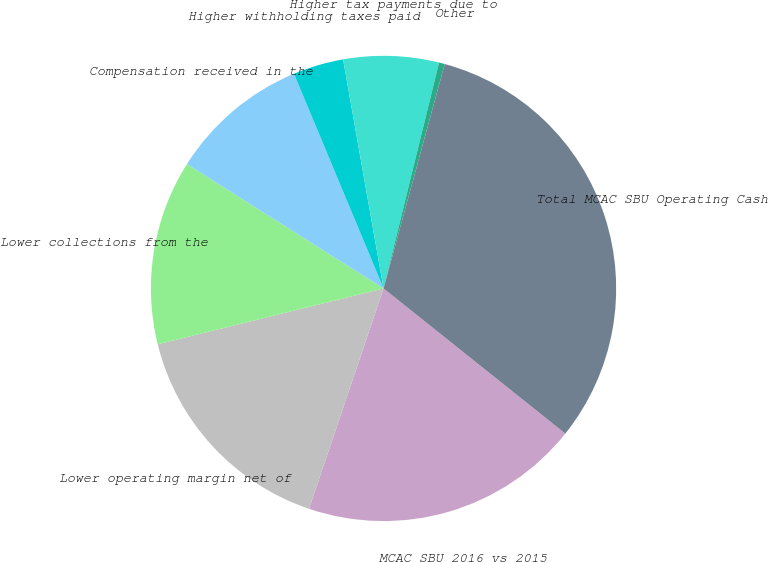Convert chart. <chart><loc_0><loc_0><loc_500><loc_500><pie_chart><fcel>MCAC SBU 2016 vs 2015<fcel>Lower operating margin net of<fcel>Lower collections from the<fcel>Compensation received in the<fcel>Higher withholding taxes paid<fcel>Higher tax payments due to<fcel>Other<fcel>Total MCAC SBU Operating Cash<nl><fcel>19.47%<fcel>15.95%<fcel>12.84%<fcel>9.73%<fcel>3.51%<fcel>6.62%<fcel>0.4%<fcel>31.49%<nl></chart> 